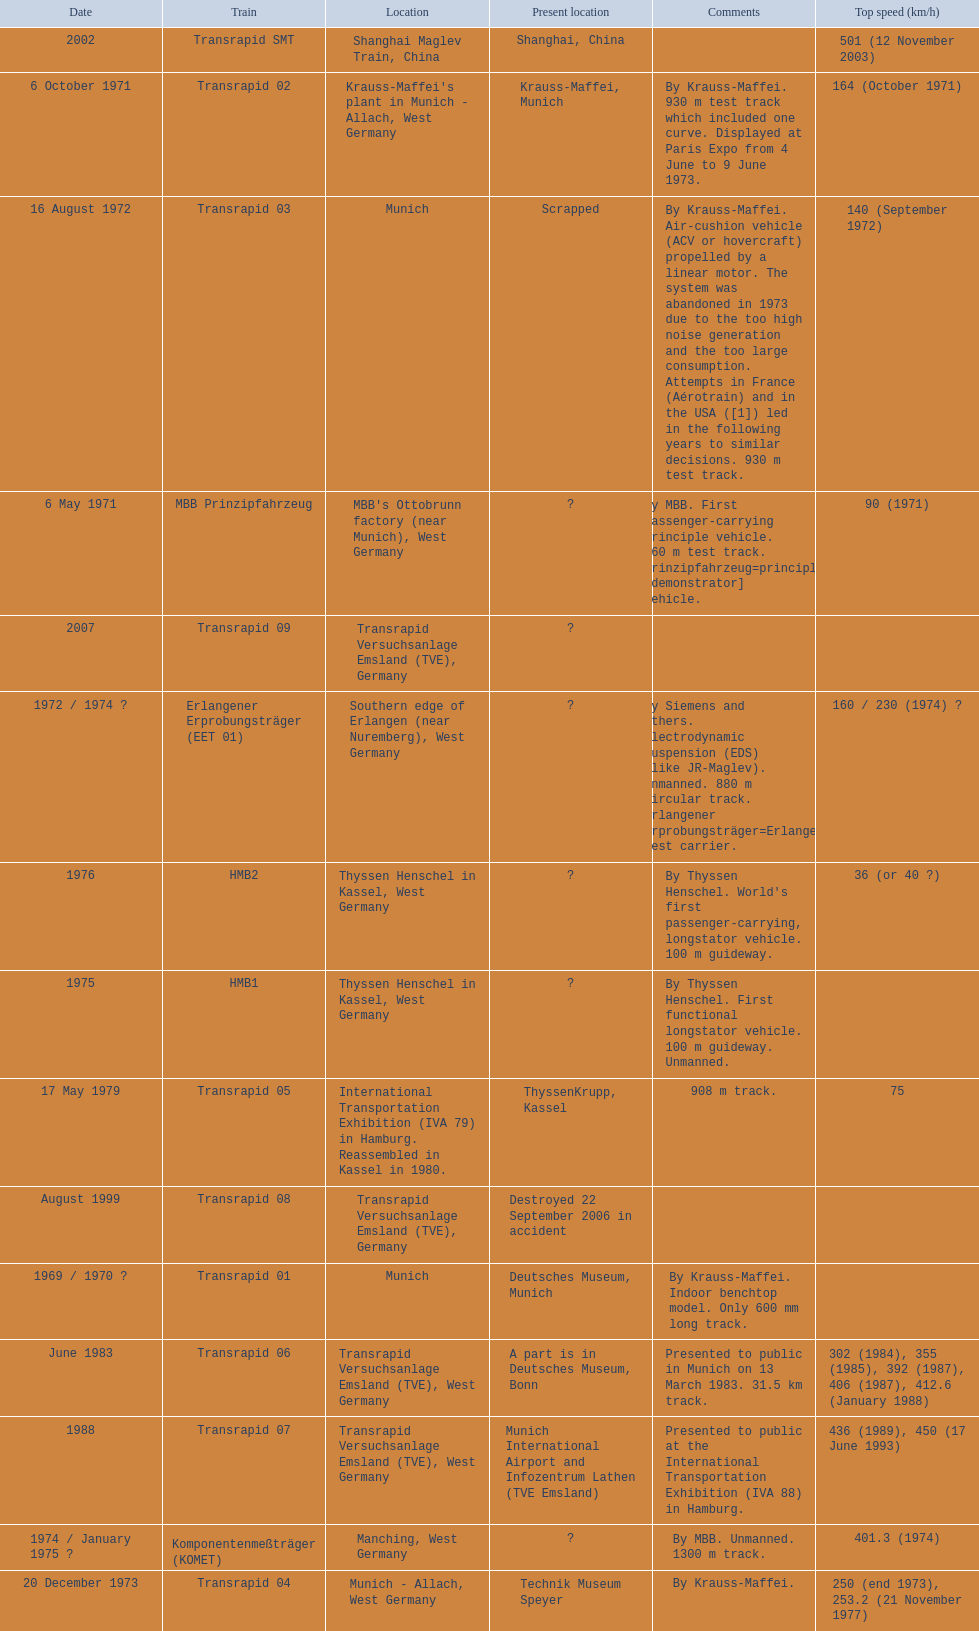What are the names of each transrapid train? Transrapid 01, MBB Prinzipfahrzeug, Transrapid 02, Transrapid 03, Erlangener Erprobungsträger (EET 01), Transrapid 04, Komponentenmeßträger (KOMET), HMB1, HMB2, Transrapid 05, Transrapid 06, Transrapid 07, Transrapid 08, Transrapid SMT, Transrapid 09. What are their listed top speeds? 90 (1971), 164 (October 1971), 140 (September 1972), 160 / 230 (1974) ?, 250 (end 1973), 253.2 (21 November 1977), 401.3 (1974), 36 (or 40 ?), 75, 302 (1984), 355 (1985), 392 (1987), 406 (1987), 412.6 (January 1988), 436 (1989), 450 (17 June 1993), 501 (12 November 2003). And which train operates at the fastest speed? Transrapid SMT. 